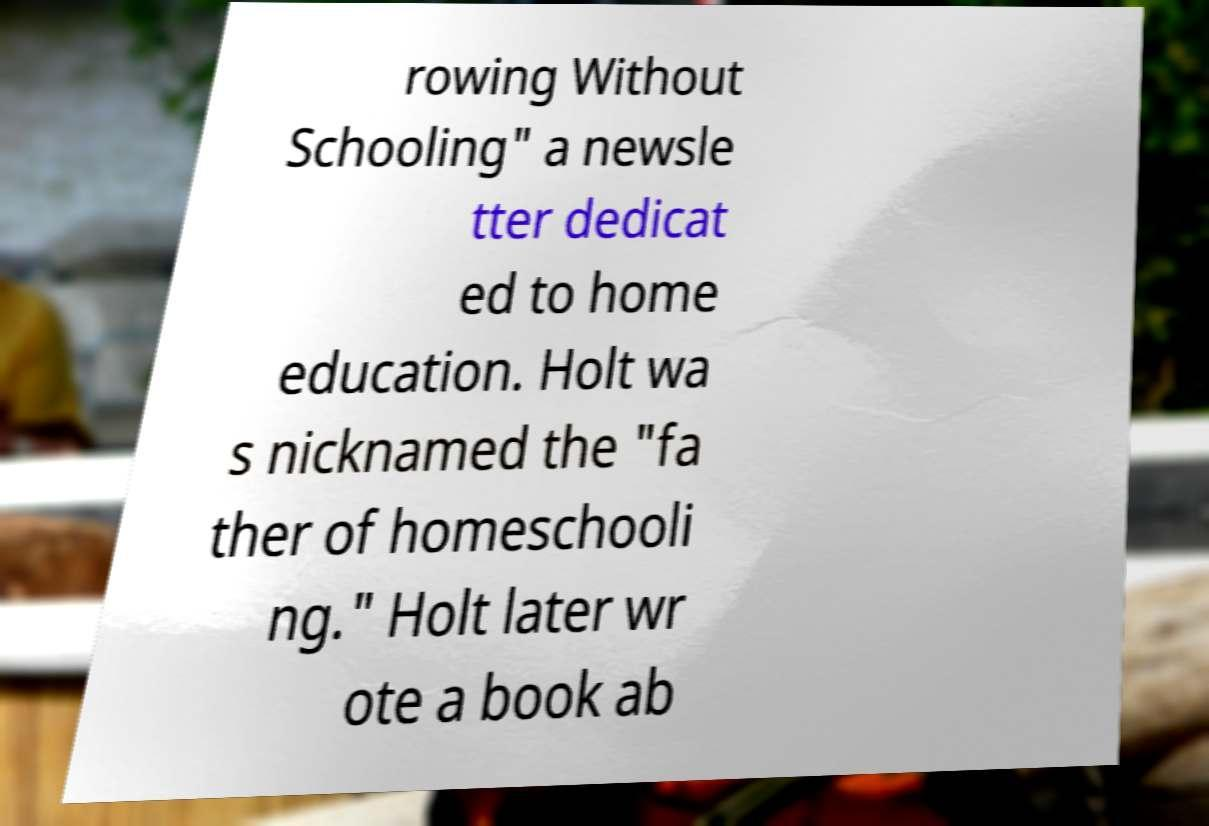Can you accurately transcribe the text from the provided image for me? rowing Without Schooling" a newsle tter dedicat ed to home education. Holt wa s nicknamed the "fa ther of homeschooli ng." Holt later wr ote a book ab 